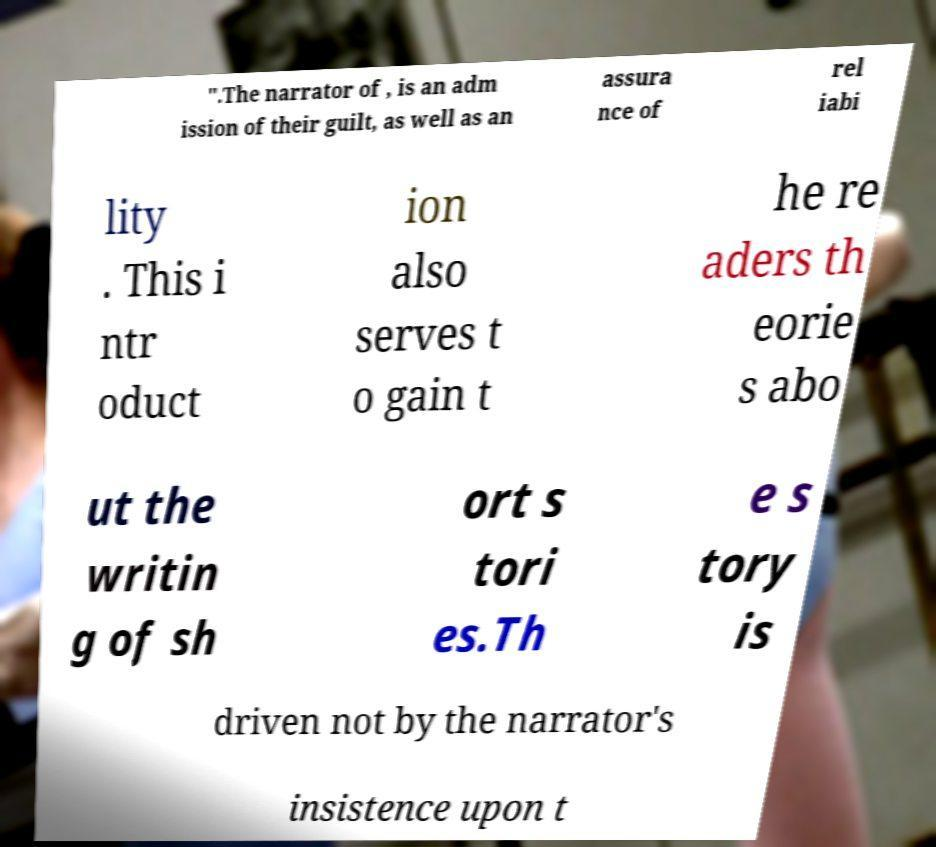Could you extract and type out the text from this image? ".The narrator of , is an adm ission of their guilt, as well as an assura nce of rel iabi lity . This i ntr oduct ion also serves t o gain t he re aders th eorie s abo ut the writin g of sh ort s tori es.Th e s tory is driven not by the narrator's insistence upon t 